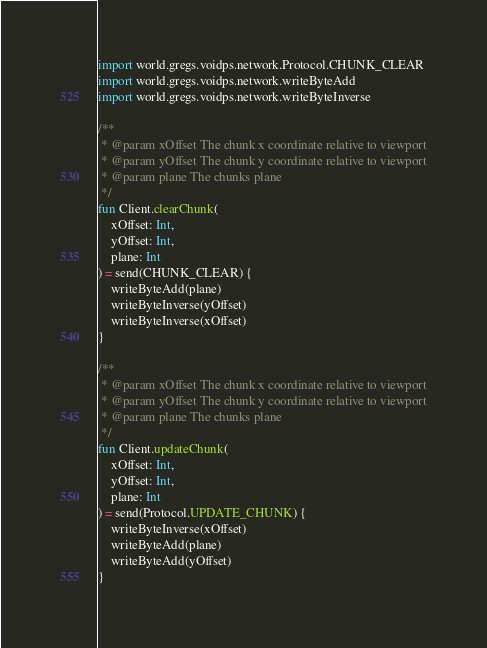<code> <loc_0><loc_0><loc_500><loc_500><_Kotlin_>import world.gregs.voidps.network.Protocol.CHUNK_CLEAR
import world.gregs.voidps.network.writeByteAdd
import world.gregs.voidps.network.writeByteInverse

/**
 * @param xOffset The chunk x coordinate relative to viewport
 * @param yOffset The chunk y coordinate relative to viewport
 * @param plane The chunks plane
 */
fun Client.clearChunk(
    xOffset: Int,
    yOffset: Int,
    plane: Int
) = send(CHUNK_CLEAR) {
    writeByteAdd(plane)
    writeByteInverse(yOffset)
    writeByteInverse(xOffset)
}

/**
 * @param xOffset The chunk x coordinate relative to viewport
 * @param yOffset The chunk y coordinate relative to viewport
 * @param plane The chunks plane
 */
fun Client.updateChunk(
    xOffset: Int,
    yOffset: Int,
    plane: Int
) = send(Protocol.UPDATE_CHUNK) {
    writeByteInverse(xOffset)
    writeByteAdd(plane)
    writeByteAdd(yOffset)
}</code> 